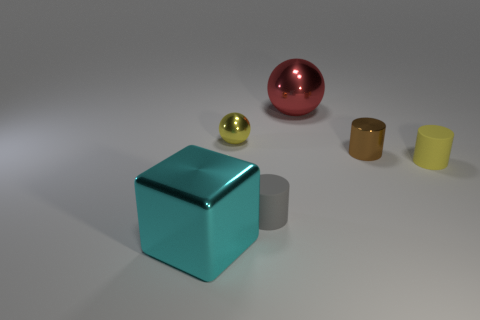The tiny metallic sphere has what color? yellow 